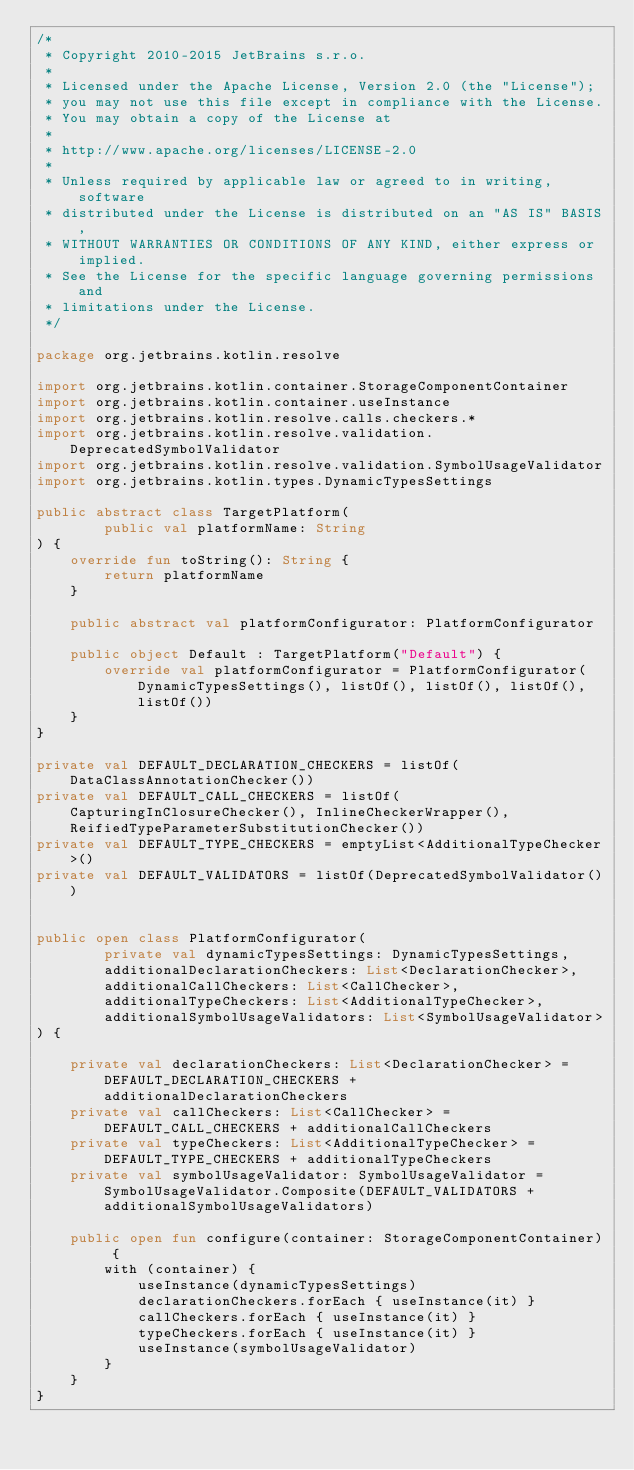Convert code to text. <code><loc_0><loc_0><loc_500><loc_500><_Kotlin_>/*
 * Copyright 2010-2015 JetBrains s.r.o.
 *
 * Licensed under the Apache License, Version 2.0 (the "License");
 * you may not use this file except in compliance with the License.
 * You may obtain a copy of the License at
 *
 * http://www.apache.org/licenses/LICENSE-2.0
 *
 * Unless required by applicable law or agreed to in writing, software
 * distributed under the License is distributed on an "AS IS" BASIS,
 * WITHOUT WARRANTIES OR CONDITIONS OF ANY KIND, either express or implied.
 * See the License for the specific language governing permissions and
 * limitations under the License.
 */

package org.jetbrains.kotlin.resolve

import org.jetbrains.kotlin.container.StorageComponentContainer
import org.jetbrains.kotlin.container.useInstance
import org.jetbrains.kotlin.resolve.calls.checkers.*
import org.jetbrains.kotlin.resolve.validation.DeprecatedSymbolValidator
import org.jetbrains.kotlin.resolve.validation.SymbolUsageValidator
import org.jetbrains.kotlin.types.DynamicTypesSettings

public abstract class TargetPlatform(
        public val platformName: String
) {
    override fun toString(): String {
        return platformName
    }

    public abstract val platformConfigurator: PlatformConfigurator

    public object Default : TargetPlatform("Default") {
        override val platformConfigurator = PlatformConfigurator(DynamicTypesSettings(), listOf(), listOf(), listOf(), listOf())
    }
}

private val DEFAULT_DECLARATION_CHECKERS = listOf(DataClassAnnotationChecker())
private val DEFAULT_CALL_CHECKERS = listOf(CapturingInClosureChecker(), InlineCheckerWrapper(), ReifiedTypeParameterSubstitutionChecker())
private val DEFAULT_TYPE_CHECKERS = emptyList<AdditionalTypeChecker>()
private val DEFAULT_VALIDATORS = listOf(DeprecatedSymbolValidator())


public open class PlatformConfigurator(
        private val dynamicTypesSettings: DynamicTypesSettings,
        additionalDeclarationCheckers: List<DeclarationChecker>,
        additionalCallCheckers: List<CallChecker>,
        additionalTypeCheckers: List<AdditionalTypeChecker>,
        additionalSymbolUsageValidators: List<SymbolUsageValidator>
) {

    private val declarationCheckers: List<DeclarationChecker> = DEFAULT_DECLARATION_CHECKERS + additionalDeclarationCheckers
    private val callCheckers: List<CallChecker> = DEFAULT_CALL_CHECKERS + additionalCallCheckers
    private val typeCheckers: List<AdditionalTypeChecker> = DEFAULT_TYPE_CHECKERS + additionalTypeCheckers
    private val symbolUsageValidator: SymbolUsageValidator = SymbolUsageValidator.Composite(DEFAULT_VALIDATORS + additionalSymbolUsageValidators)

    public open fun configure(container: StorageComponentContainer) {
        with (container) {
            useInstance(dynamicTypesSettings)
            declarationCheckers.forEach { useInstance(it) }
            callCheckers.forEach { useInstance(it) }
            typeCheckers.forEach { useInstance(it) }
            useInstance(symbolUsageValidator)
        }
    }
}</code> 